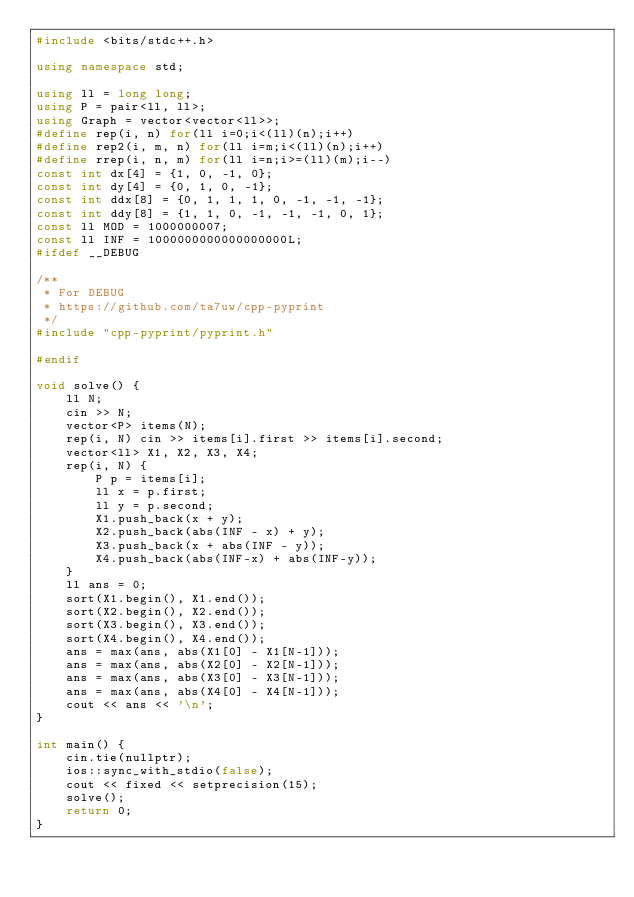<code> <loc_0><loc_0><loc_500><loc_500><_C++_>#include <bits/stdc++.h>

using namespace std;

using ll = long long;
using P = pair<ll, ll>;
using Graph = vector<vector<ll>>;
#define rep(i, n) for(ll i=0;i<(ll)(n);i++)
#define rep2(i, m, n) for(ll i=m;i<(ll)(n);i++)
#define rrep(i, n, m) for(ll i=n;i>=(ll)(m);i--)
const int dx[4] = {1, 0, -1, 0};
const int dy[4] = {0, 1, 0, -1};
const int ddx[8] = {0, 1, 1, 1, 0, -1, -1, -1};
const int ddy[8] = {1, 1, 0, -1, -1, -1, 0, 1};
const ll MOD = 1000000007;
const ll INF = 1000000000000000000L;
#ifdef __DEBUG

/**
 * For DEBUG
 * https://github.com/ta7uw/cpp-pyprint
 */
#include "cpp-pyprint/pyprint.h"

#endif

void solve() {
    ll N;
    cin >> N;
    vector<P> items(N);
    rep(i, N) cin >> items[i].first >> items[i].second;
    vector<ll> X1, X2, X3, X4;
    rep(i, N) {
        P p = items[i];
        ll x = p.first;
        ll y = p.second;
        X1.push_back(x + y);
        X2.push_back(abs(INF - x) + y);
        X3.push_back(x + abs(INF - y));
        X4.push_back(abs(INF-x) + abs(INF-y));
    }
    ll ans = 0;
    sort(X1.begin(), X1.end());
    sort(X2.begin(), X2.end());
    sort(X3.begin(), X3.end());
    sort(X4.begin(), X4.end());
    ans = max(ans, abs(X1[0] - X1[N-1]));
    ans = max(ans, abs(X2[0] - X2[N-1]));
    ans = max(ans, abs(X3[0] - X3[N-1]));
    ans = max(ans, abs(X4[0] - X4[N-1]));
    cout << ans << '\n';
}

int main() {
    cin.tie(nullptr);
    ios::sync_with_stdio(false);
    cout << fixed << setprecision(15);
    solve();
    return 0;
}
</code> 